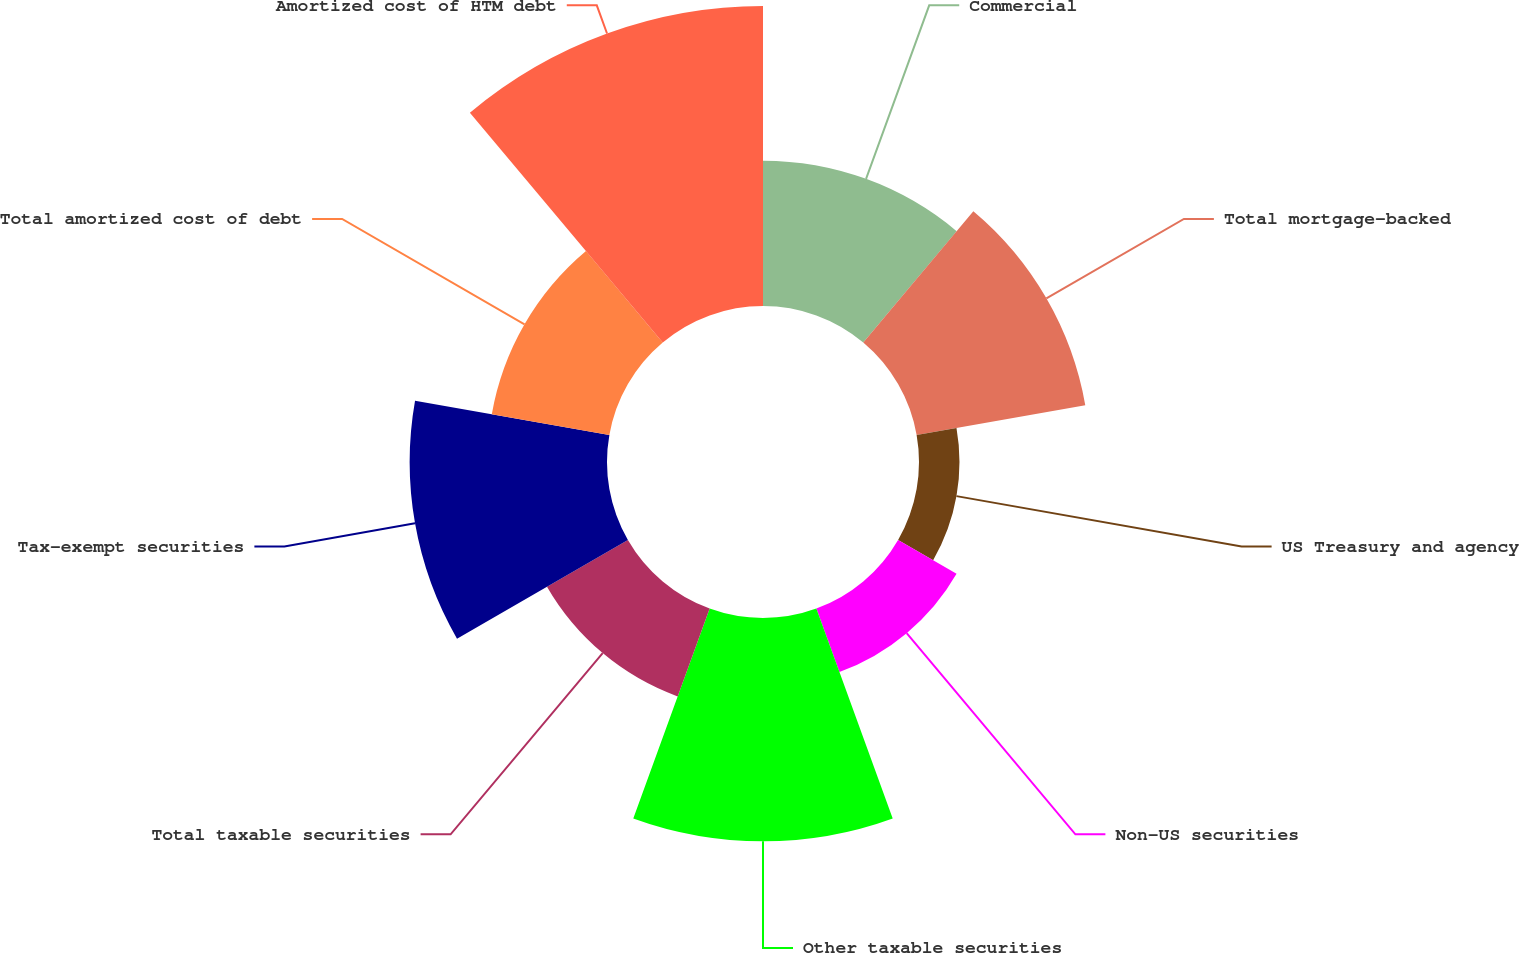Convert chart. <chart><loc_0><loc_0><loc_500><loc_500><pie_chart><fcel>Commercial<fcel>Total mortgage-backed<fcel>US Treasury and agency<fcel>Non-US securities<fcel>Other taxable securities<fcel>Total taxable securities<fcel>Tax-exempt securities<fcel>Total amortized cost of debt<fcel>Amortized cost of HTM debt<nl><fcel>10.7%<fcel>12.61%<fcel>2.98%<fcel>4.97%<fcel>16.44%<fcel>6.88%<fcel>14.53%<fcel>8.79%<fcel>22.09%<nl></chart> 